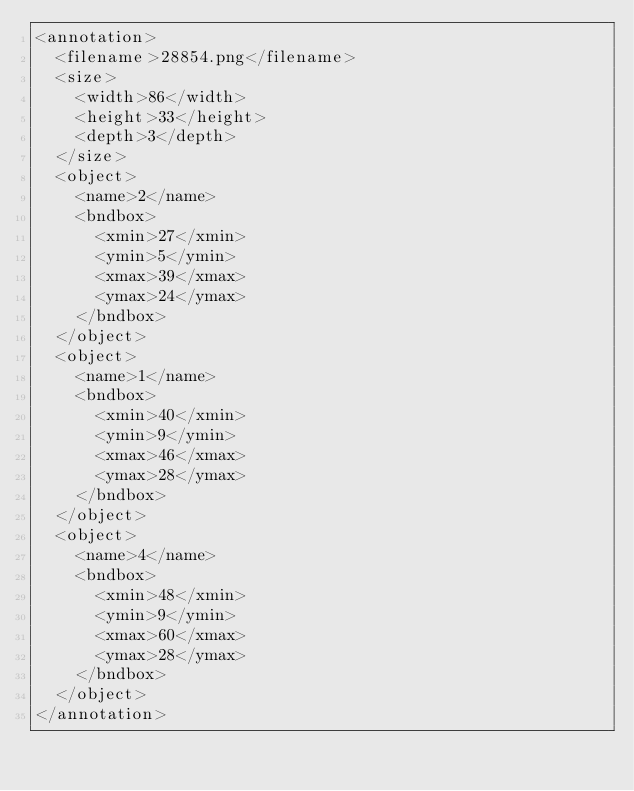Convert code to text. <code><loc_0><loc_0><loc_500><loc_500><_XML_><annotation>
  <filename>28854.png</filename>
  <size>
    <width>86</width>
    <height>33</height>
    <depth>3</depth>
  </size>
  <object>
    <name>2</name>
    <bndbox>
      <xmin>27</xmin>
      <ymin>5</ymin>
      <xmax>39</xmax>
      <ymax>24</ymax>
    </bndbox>
  </object>
  <object>
    <name>1</name>
    <bndbox>
      <xmin>40</xmin>
      <ymin>9</ymin>
      <xmax>46</xmax>
      <ymax>28</ymax>
    </bndbox>
  </object>
  <object>
    <name>4</name>
    <bndbox>
      <xmin>48</xmin>
      <ymin>9</ymin>
      <xmax>60</xmax>
      <ymax>28</ymax>
    </bndbox>
  </object>
</annotation>
</code> 